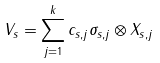<formula> <loc_0><loc_0><loc_500><loc_500>V _ { s } = \sum _ { j = 1 } ^ { k } c _ { s , j } \sigma _ { s , j } \otimes X _ { s , j }</formula> 